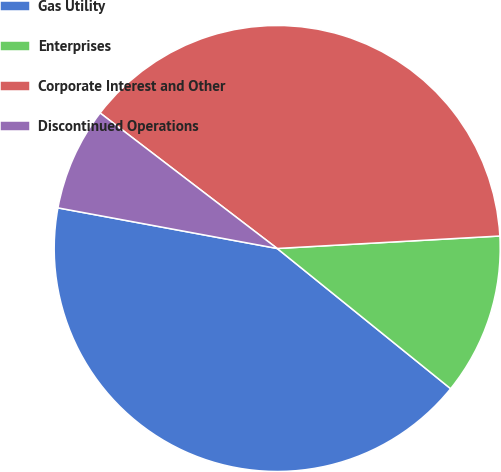<chart> <loc_0><loc_0><loc_500><loc_500><pie_chart><fcel>Gas Utility<fcel>Enterprises<fcel>Corporate Interest and Other<fcel>Discontinued Operations<nl><fcel>42.09%<fcel>11.71%<fcel>38.71%<fcel>7.48%<nl></chart> 